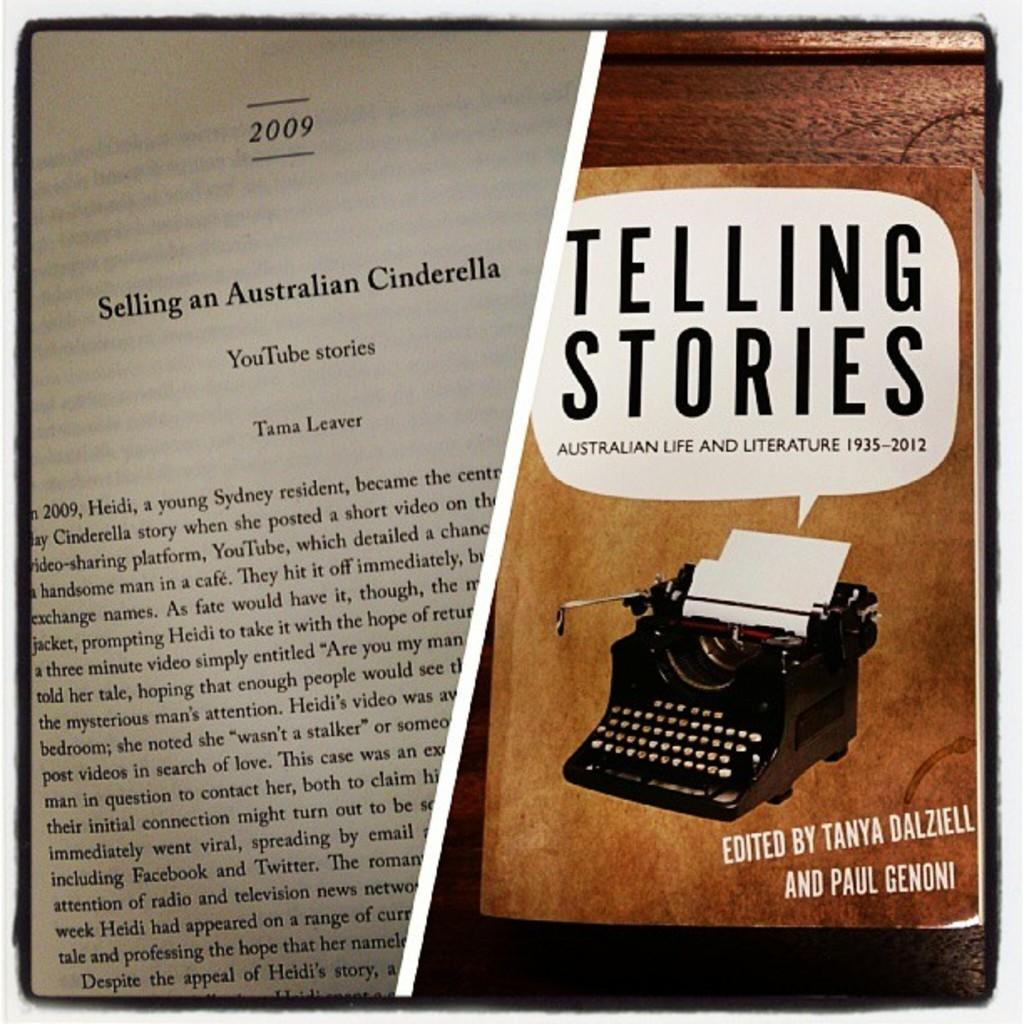<image>
Write a terse but informative summary of the picture. A page out of the book Telling Stories by Tanya Dalziell and Paul Genoni. 